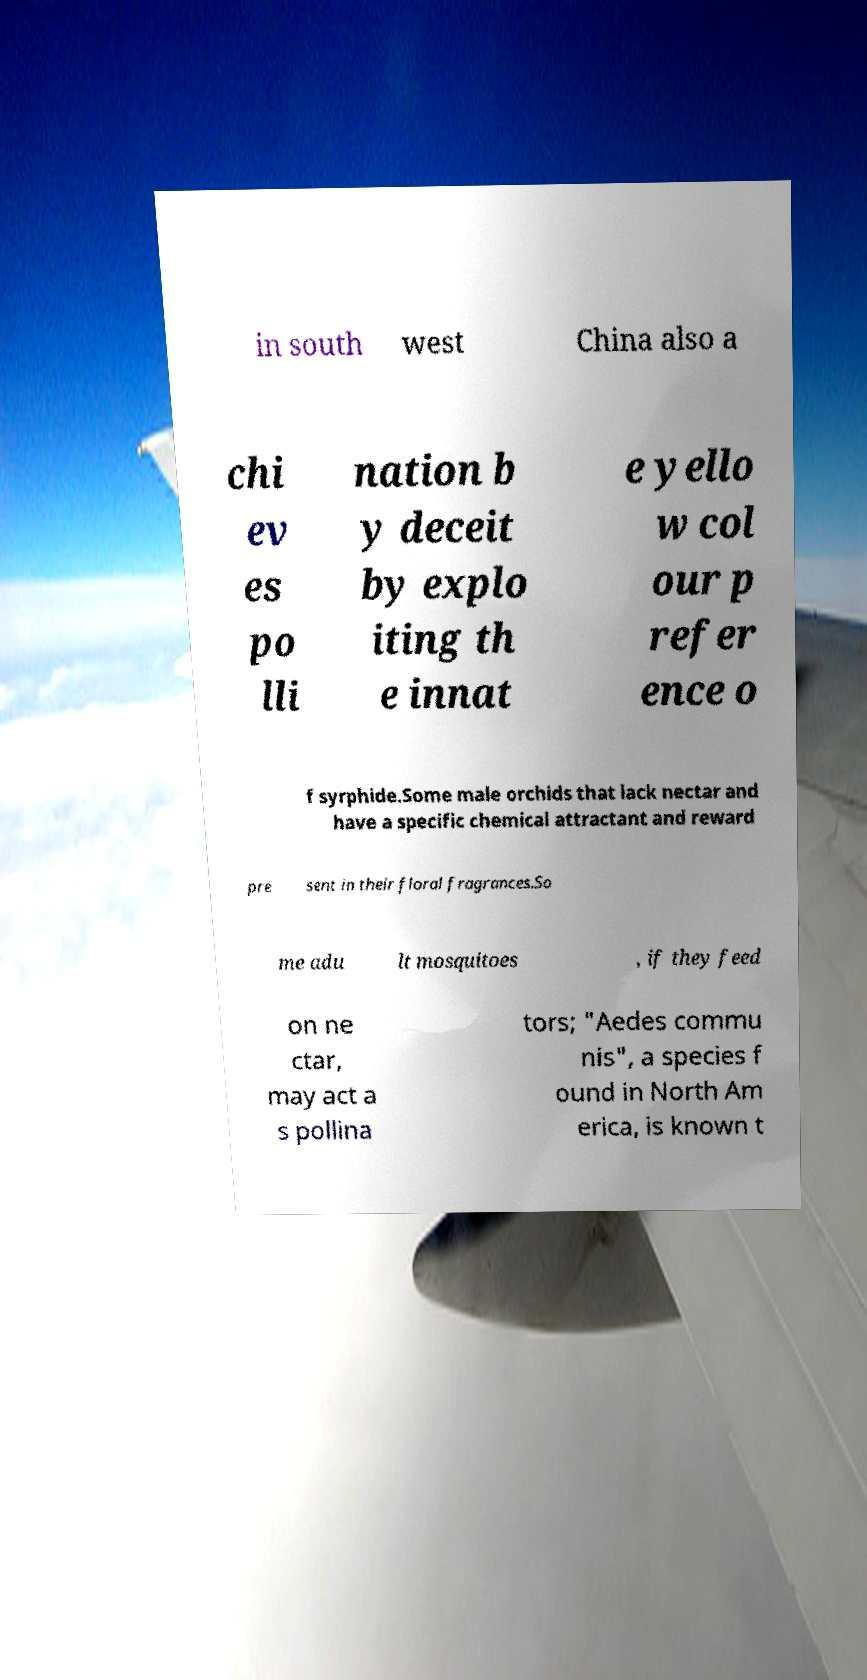For documentation purposes, I need the text within this image transcribed. Could you provide that? in south west China also a chi ev es po lli nation b y deceit by explo iting th e innat e yello w col our p refer ence o f syrphide.Some male orchids that lack nectar and have a specific chemical attractant and reward pre sent in their floral fragrances.So me adu lt mosquitoes , if they feed on ne ctar, may act a s pollina tors; "Aedes commu nis", a species f ound in North Am erica, is known t 